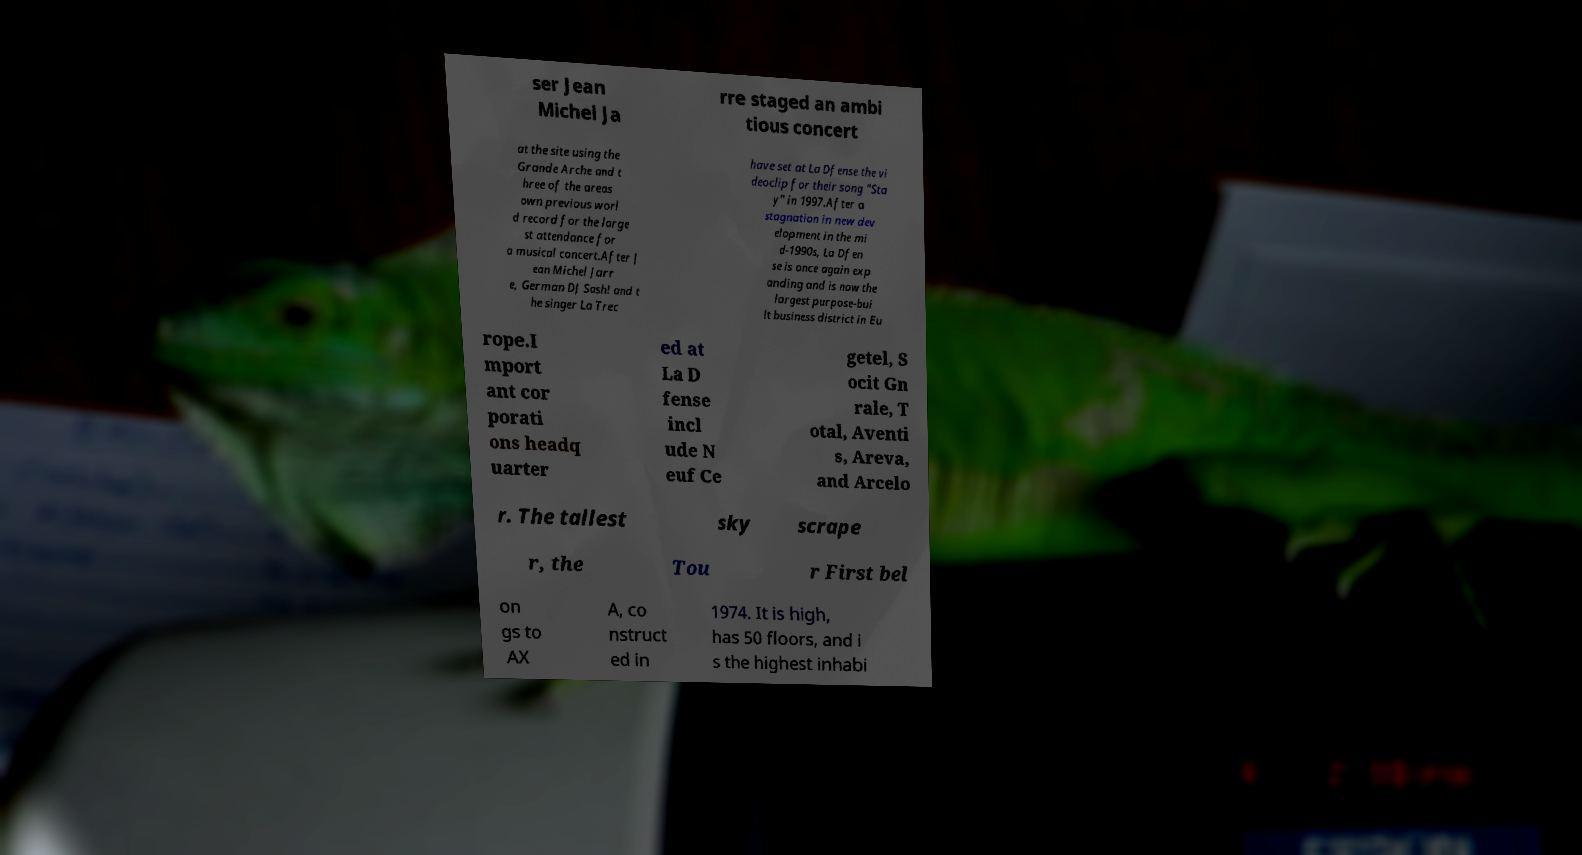For documentation purposes, I need the text within this image transcribed. Could you provide that? ser Jean Michel Ja rre staged an ambi tious concert at the site using the Grande Arche and t hree of the areas own previous worl d record for the large st attendance for a musical concert.After J ean Michel Jarr e, German DJ Sash! and t he singer La Trec have set at La Dfense the vi deoclip for their song "Sta y" in 1997.After a stagnation in new dev elopment in the mi d-1990s, La Dfen se is once again exp anding and is now the largest purpose-bui lt business district in Eu rope.I mport ant cor porati ons headq uarter ed at La D fense incl ude N euf Ce getel, S ocit Gn rale, T otal, Aventi s, Areva, and Arcelo r. The tallest sky scrape r, the Tou r First bel on gs to AX A, co nstruct ed in 1974. It is high, has 50 floors, and i s the highest inhabi 